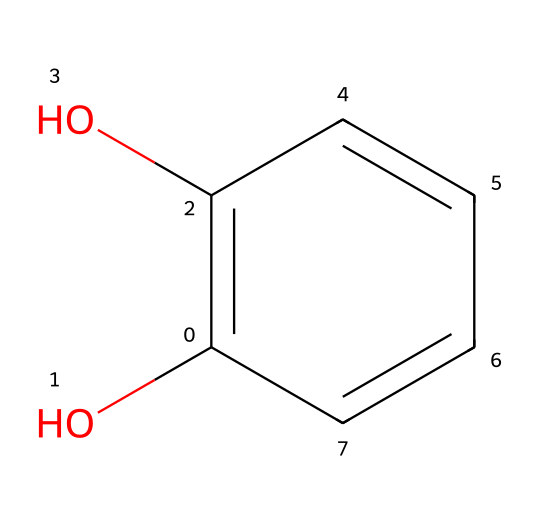What is the name of this chemical? The SMILES representation indicates a compound with two hydroxyl groups attached to a benzene ring, which is known as catechol.
Answer: catechol How many hydroxyl groups does catechol have? The structure shows two -OH (hydroxyl) groups attached to the carbon atoms of the benzene ring, confirming there are two hydroxyl groups.
Answer: two What is the molecular formula of catechol? Based on the structure, catechol consists of six carbon atoms, six hydrogen atoms, and two oxygen atoms, leading to the molecular formula C6H6O2.
Answer: C6H6O2 Which functional groups are present in catechol? The compound contains hydroxyl groups as the primary functional groups, evident from the -OH groups attached to the benzene ring.
Answer: hydroxyl What type of compound is catechol classified as? The presence of a benzene ring with hydroxyl groups classifies catechol as a phenol, a specific type of aromatic compound.
Answer: phenol How many carbon atoms are in catechol? Counting the carbon atoms in the structure reveals there are six carbon atoms in total.
Answer: six What property is influenced by the presence of hydroxyl groups in catechol? The presence of hydroxyl groups in catechol increases its polarity, which affects its solubility in water and reactivity with biological systems.
Answer: polarity 